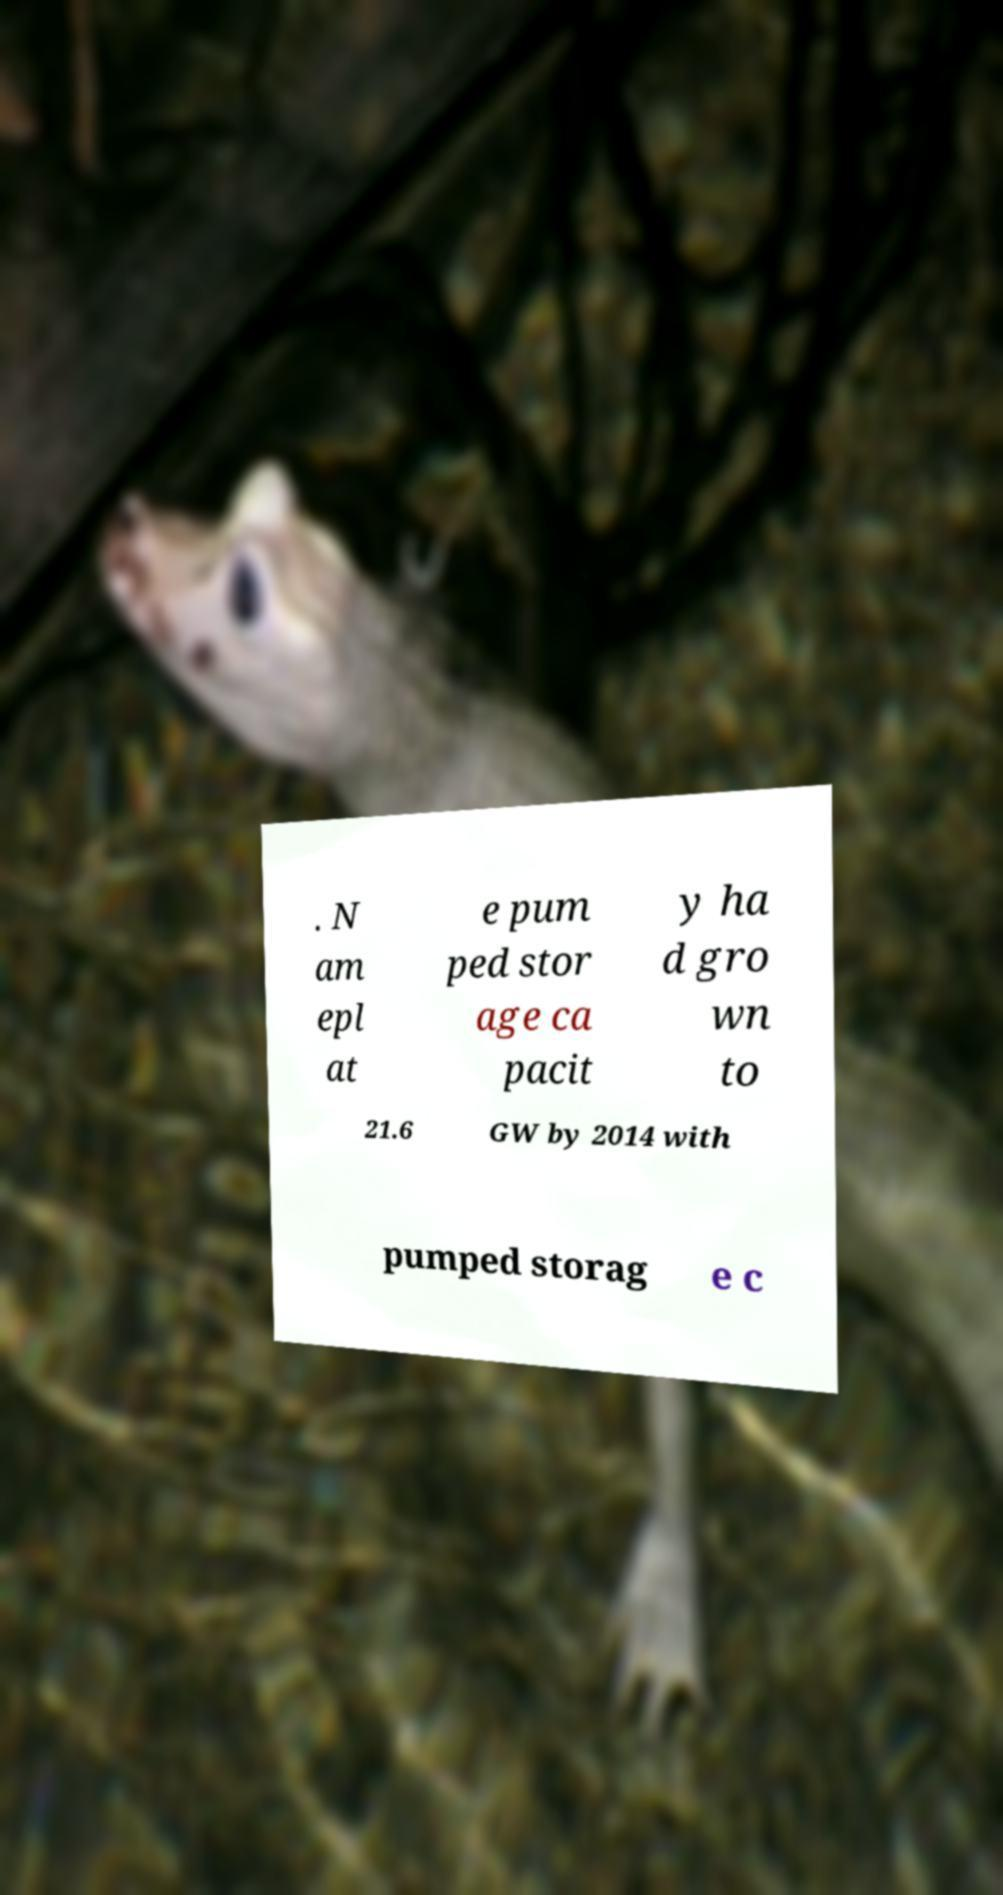Please identify and transcribe the text found in this image. . N am epl at e pum ped stor age ca pacit y ha d gro wn to 21.6 GW by 2014 with pumped storag e c 